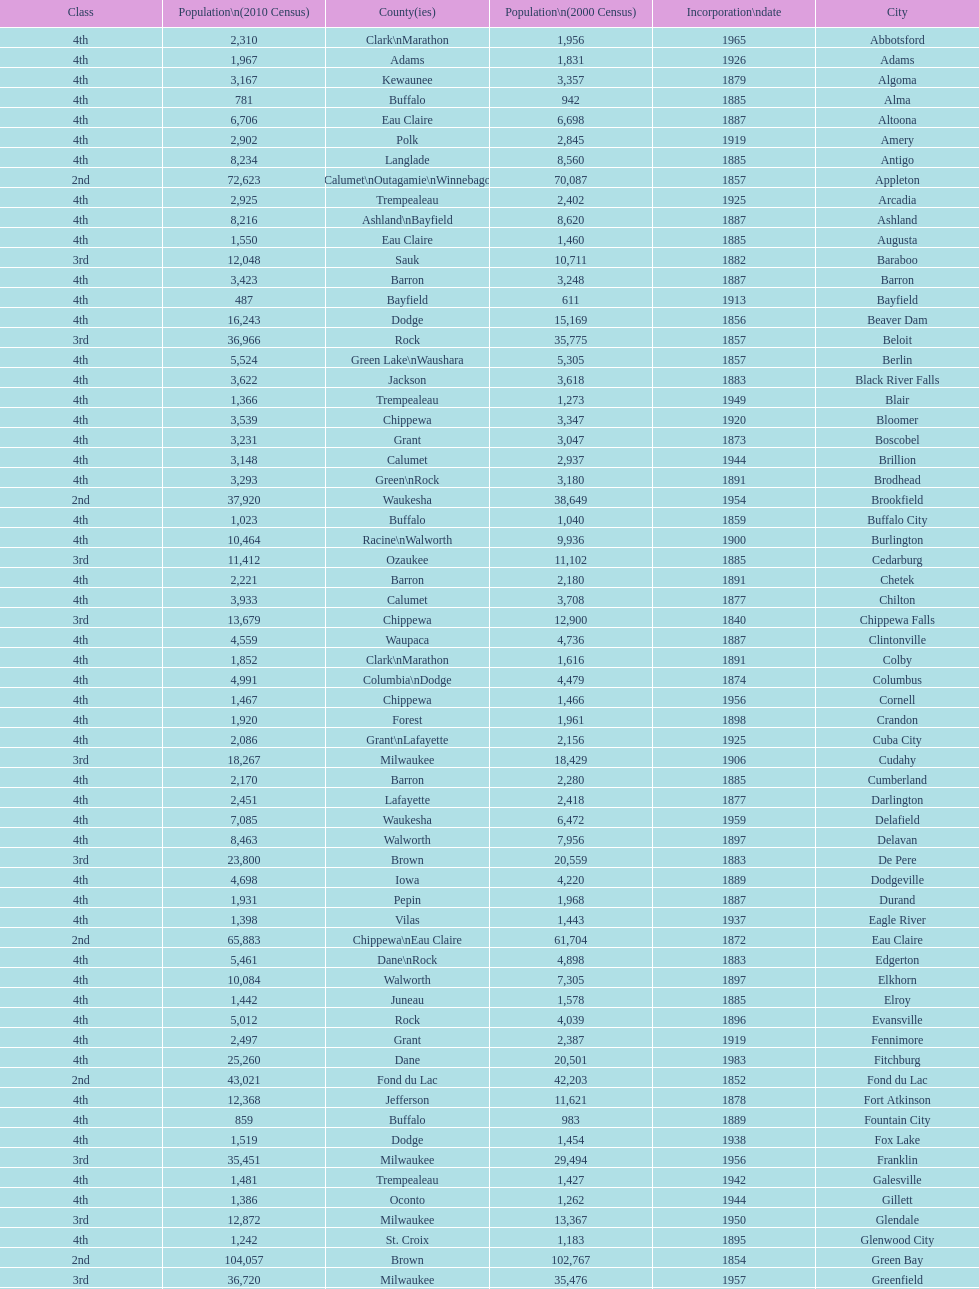Which city has the most population in the 2010 census? Milwaukee. 